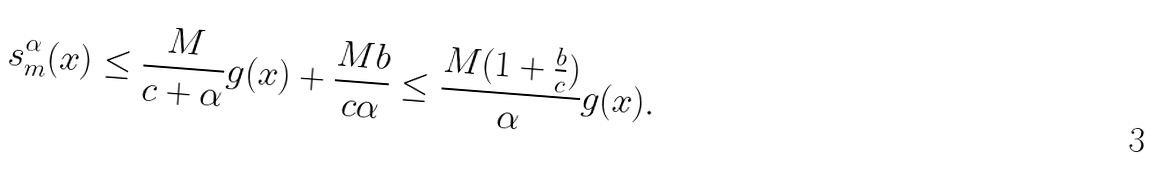<formula> <loc_0><loc_0><loc_500><loc_500>s ^ { \alpha } _ { m } ( x ) \leq \frac { M } { c + \alpha } g ( x ) + \frac { M b } { c \alpha } \leq \frac { M ( 1 + \frac { b } { c } ) } { \alpha } g ( x ) .</formula> 